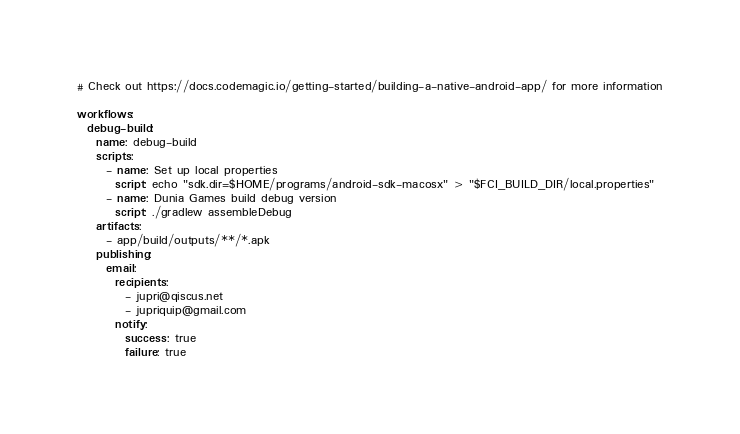<code> <loc_0><loc_0><loc_500><loc_500><_YAML_># Check out https://docs.codemagic.io/getting-started/building-a-native-android-app/ for more information

workflows:
  debug-build:
    name: debug-build
    scripts:
      - name: Set up local properties
        script: echo "sdk.dir=$HOME/programs/android-sdk-macosx" > "$FCI_BUILD_DIR/local.properties"
      - name: Dunia Games build debug version
        script: ./gradlew assembleDebug
    artifacts:
      - app/build/outputs/**/*.apk
    publishing:
      email:
        recipients:
          - jupri@qiscus.net
          - jupriquip@gmail.com
        notify:
          success: true
          failure: true</code> 